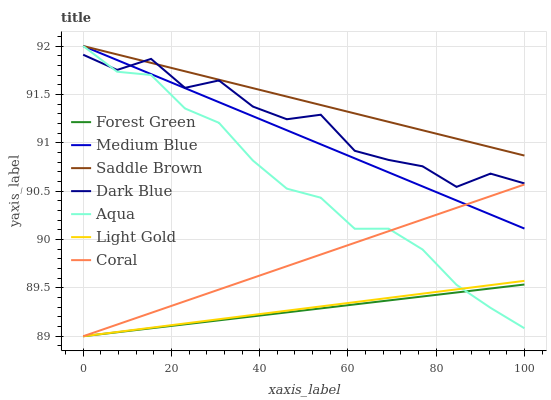Does Forest Green have the minimum area under the curve?
Answer yes or no. Yes. Does Saddle Brown have the maximum area under the curve?
Answer yes or no. Yes. Does Coral have the minimum area under the curve?
Answer yes or no. No. Does Coral have the maximum area under the curve?
Answer yes or no. No. Is Medium Blue the smoothest?
Answer yes or no. Yes. Is Dark Blue the roughest?
Answer yes or no. Yes. Is Coral the smoothest?
Answer yes or no. No. Is Coral the roughest?
Answer yes or no. No. Does Aqua have the lowest value?
Answer yes or no. No. Does Coral have the highest value?
Answer yes or no. No. Is Forest Green less than Medium Blue?
Answer yes or no. Yes. Is Dark Blue greater than Coral?
Answer yes or no. Yes. Does Forest Green intersect Medium Blue?
Answer yes or no. No. 